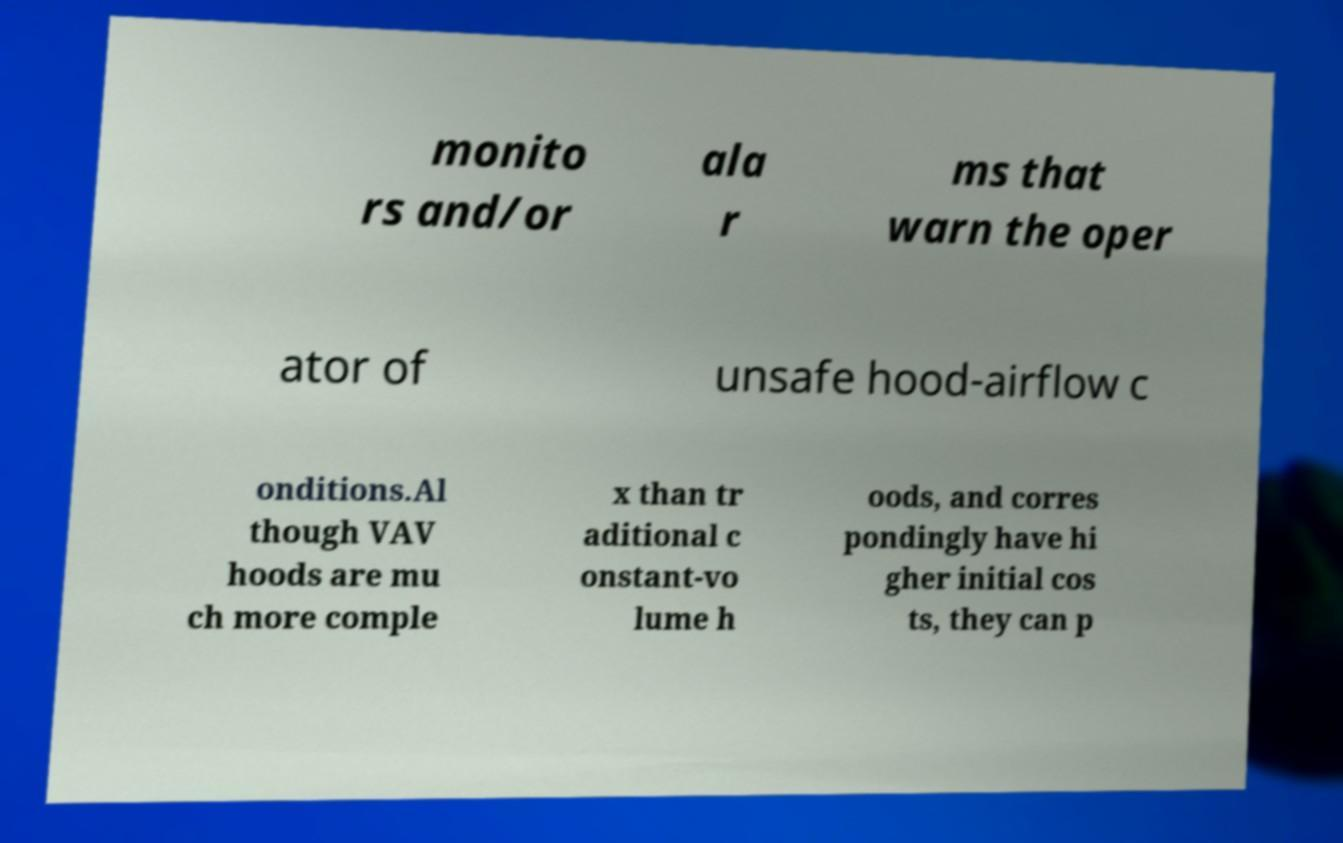Can you read and provide the text displayed in the image?This photo seems to have some interesting text. Can you extract and type it out for me? monito rs and/or ala r ms that warn the oper ator of unsafe hood-airflow c onditions.Al though VAV hoods are mu ch more comple x than tr aditional c onstant-vo lume h oods, and corres pondingly have hi gher initial cos ts, they can p 